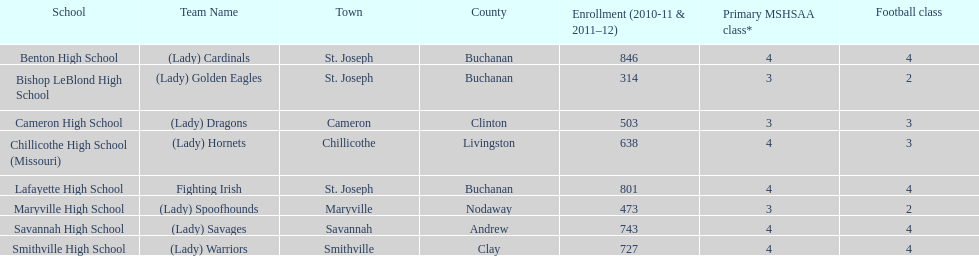Which schools are situated in the same town as bishop leblond? Benton High School, Lafayette High School. 